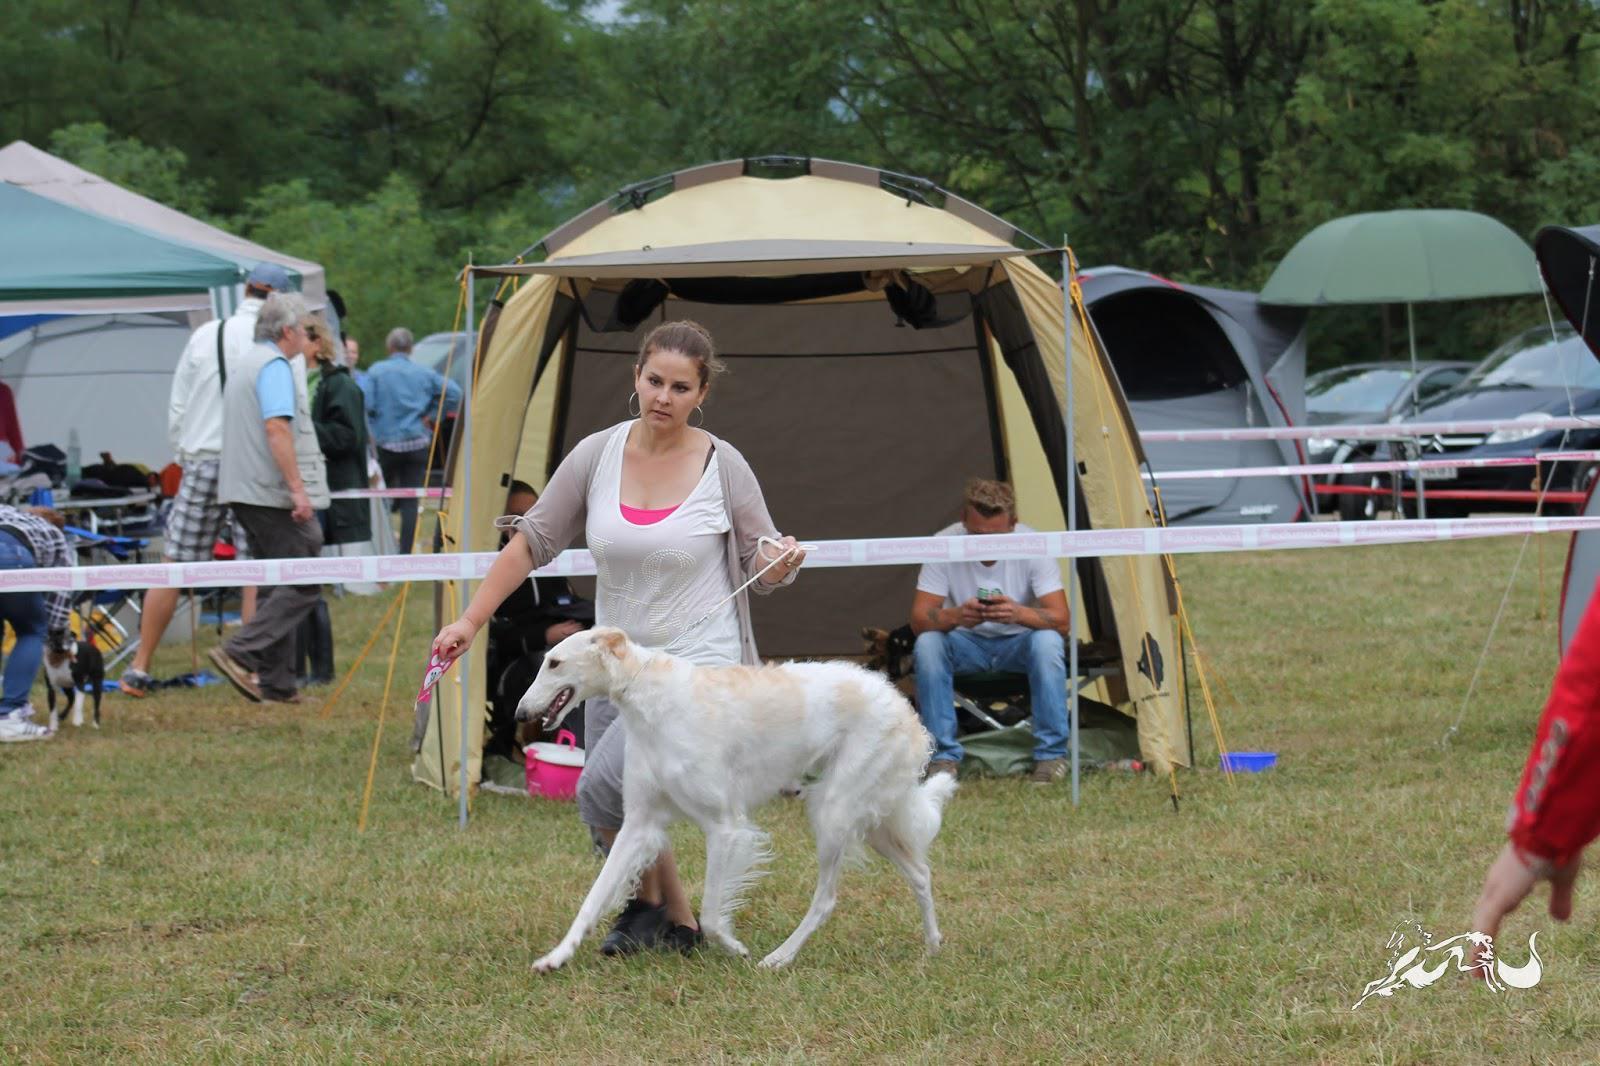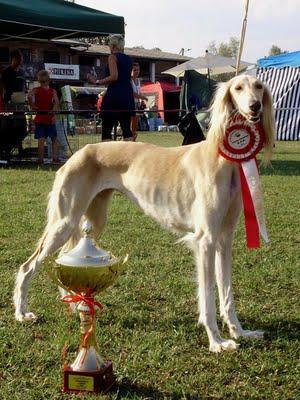The first image is the image on the left, the second image is the image on the right. For the images displayed, is the sentence "In at least one image there is a woman whose body is facing left  while showing a tall dog with some white fur." factually correct? Answer yes or no. Yes. The first image is the image on the left, the second image is the image on the right. Evaluate the accuracy of this statement regarding the images: "A person is training a long haired dog.". Is it true? Answer yes or no. Yes. 